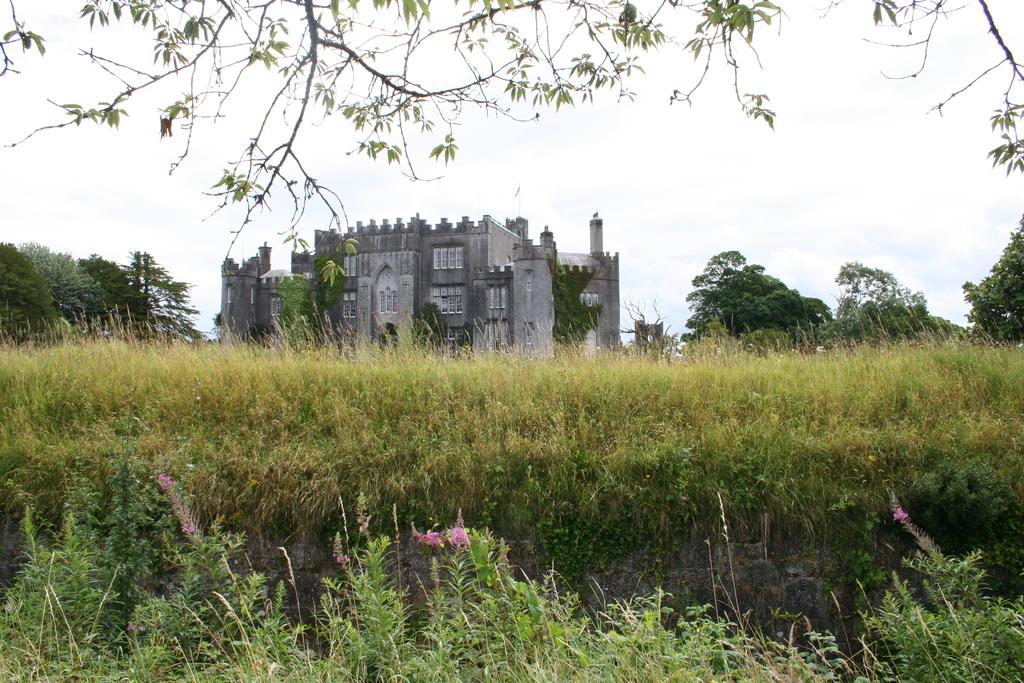What type of vegetation is visible at the front of the image? There are trees in front of the image. What type of ground cover is present at the bottom of the image? There is grass at the bottom of the image. What can be seen in the background of the image? There are trees and a building in the background of the image. What part of the natural environment is visible in the background of the image? The sky is visible in the background of the image. What channel is the head of the building tuned to in the image? There is no head or channel present in the image; it features trees, grass, a building, and the sky. 